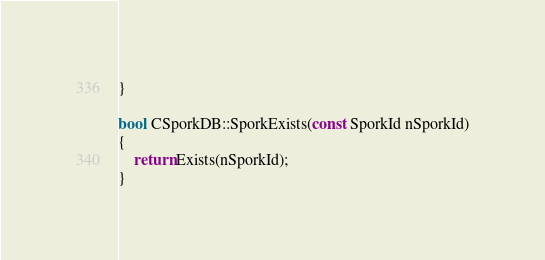Convert code to text. <code><loc_0><loc_0><loc_500><loc_500><_C++_>}

bool CSporkDB::SporkExists(const SporkId nSporkId)
{
    return Exists(nSporkId);
}
</code> 